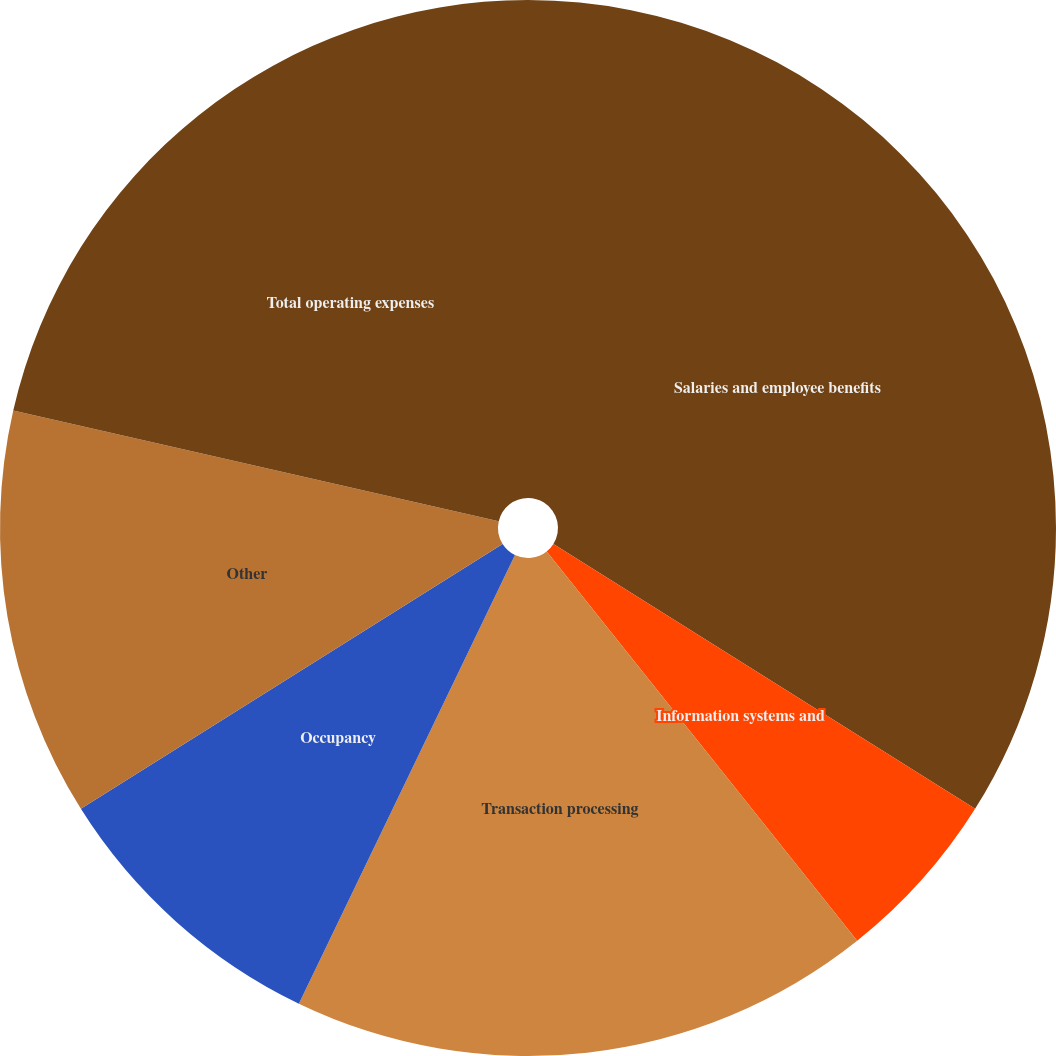Convert chart. <chart><loc_0><loc_0><loc_500><loc_500><pie_chart><fcel>Salaries and employee benefits<fcel>Information systems and<fcel>Transaction processing<fcel>Occupancy<fcel>Other<fcel>Total operating expenses<nl><fcel>33.93%<fcel>5.36%<fcel>17.86%<fcel>8.93%<fcel>12.5%<fcel>21.43%<nl></chart> 